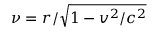<formula> <loc_0><loc_0><loc_500><loc_500>\nu = r / \sqrt { 1 - v ^ { 2 } / c ^ { 2 } }</formula> 